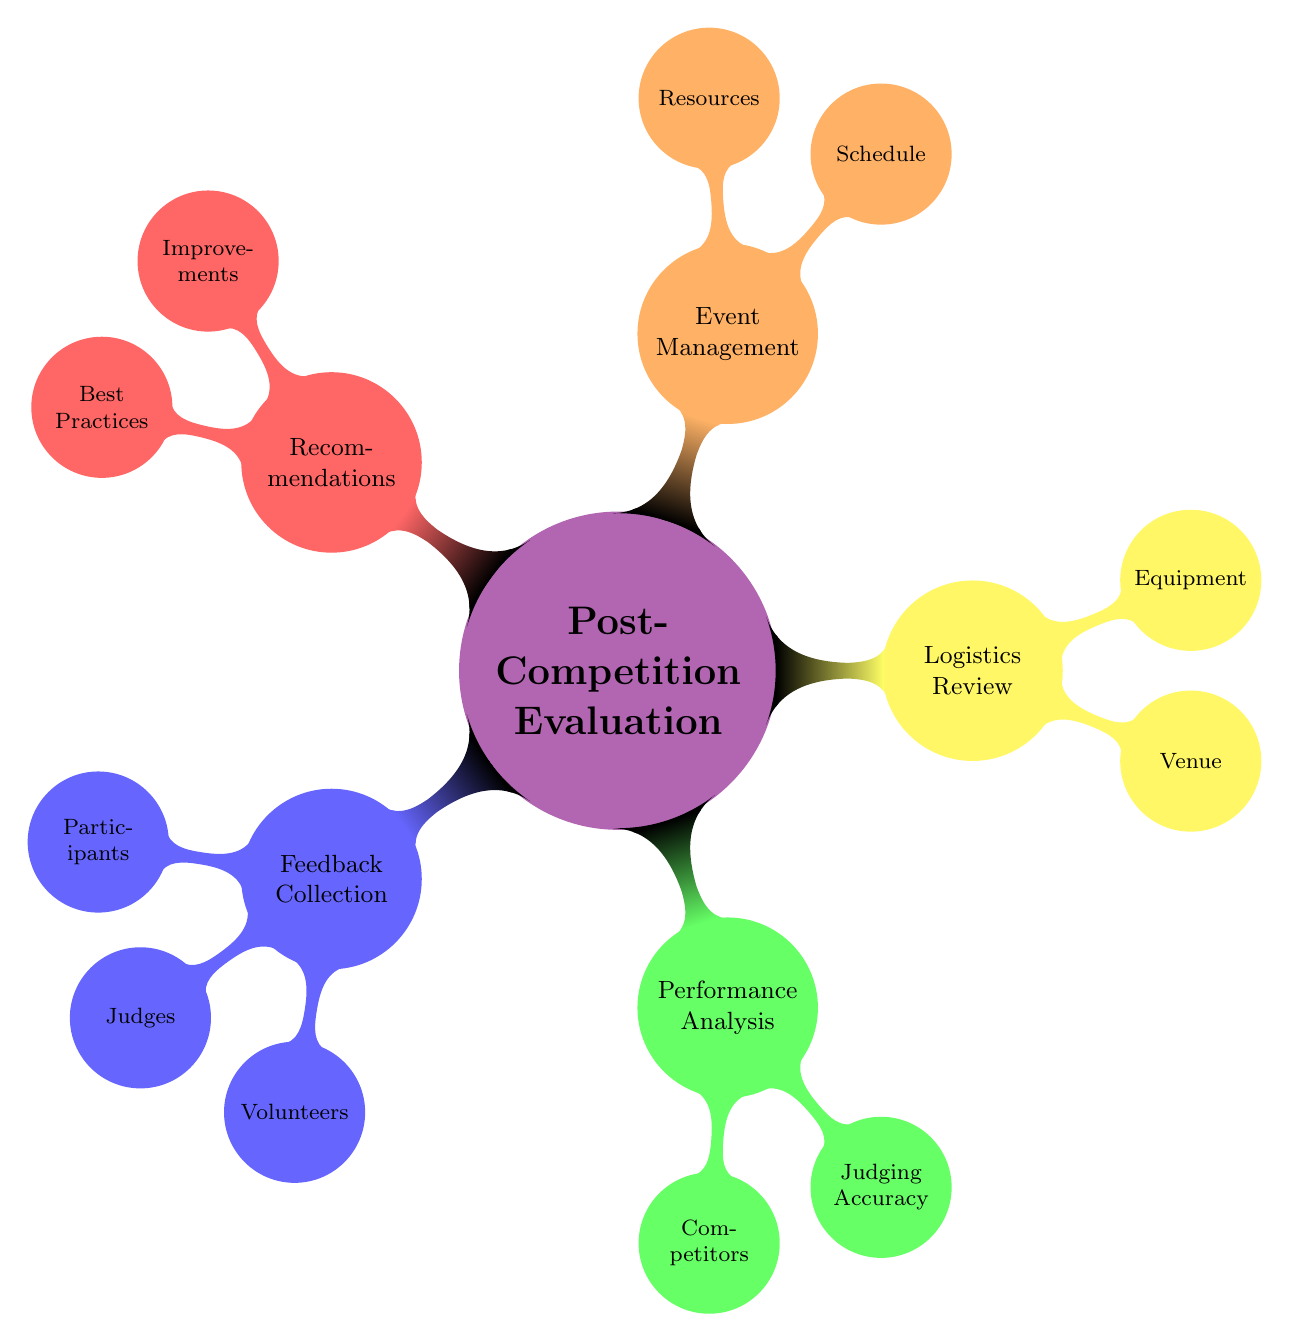What is the main topic of the diagram? The main topic is visually represented at the center of the mind map, labeled as "Post-Competition Evaluation."
Answer: Post-Competition Evaluation How many main branches extend from the central topic? Counting the branches extending from "Post-Competition Evaluation," there are five distinct categories: Feedback Collection, Performance Analysis, Logistics Review, Event Management, and Recommendations.
Answer: 5 What feedback categories are included in the Feedback Collection branch? The Feedback Collection branch includes three specific categories: Participants Feedback, Judges Feedback, and Volunteers Feedback.
Answer: Participants, Judges, Volunteers What does the Performance Analysis branch evaluate? This branch evaluates two areas: Competitors Performance, which focuses on results and skill levels, and Judging Accuracy, which reviews score consistency and fairness.
Answer: Competitors Performance and Judging Accuracy Which branch assesses the suitability of the venue? Venue Assessment is part of the Logistics Review branch, which specifically evaluates the suitability and amenities of the venue.
Answer: Logistics Review How is resource efficiency described under Event Management? Under Event Management, the Resource Utilization node offers insights into how efficiently resources such as time, money, and people were used during the event.
Answer: Resource Utilization What type of feedback is collected from judges? The Judges Feedback category indicates that opinions and suggestions from judges are collected through surveys or discussions to improve future events.
Answer: Opinions and suggestions What is the purpose of the Recommendations branch? The Recommendations branch serves to provide improvements and best practices based on the evaluations and feedback gathered post-competition.
Answer: Suggestions for future competitions and successful strategies 